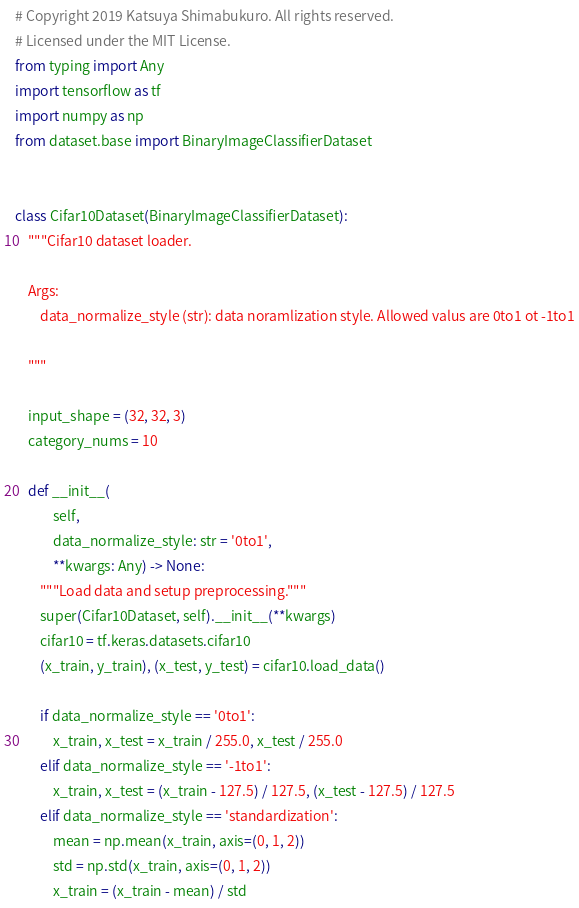<code> <loc_0><loc_0><loc_500><loc_500><_Python_># Copyright 2019 Katsuya Shimabukuro. All rights reserved.
# Licensed under the MIT License.
from typing import Any
import tensorflow as tf
import numpy as np
from dataset.base import BinaryImageClassifierDataset


class Cifar10Dataset(BinaryImageClassifierDataset):
    """Cifar10 dataset loader.

    Args:
        data_normalize_style (str): data noramlization style. Allowed valus are 0to1 ot -1to1

    """

    input_shape = (32, 32, 3)
    category_nums = 10

    def __init__(
            self,
            data_normalize_style: str = '0to1',
            **kwargs: Any) -> None:
        """Load data and setup preprocessing."""
        super(Cifar10Dataset, self).__init__(**kwargs)
        cifar10 = tf.keras.datasets.cifar10
        (x_train, y_train), (x_test, y_test) = cifar10.load_data()

        if data_normalize_style == '0to1':
            x_train, x_test = x_train / 255.0, x_test / 255.0
        elif data_normalize_style == '-1to1':
            x_train, x_test = (x_train - 127.5) / 127.5, (x_test - 127.5) / 127.5
        elif data_normalize_style == 'standardization':
            mean = np.mean(x_train, axis=(0, 1, 2))
            std = np.std(x_train, axis=(0, 1, 2))
            x_train = (x_train - mean) / std</code> 